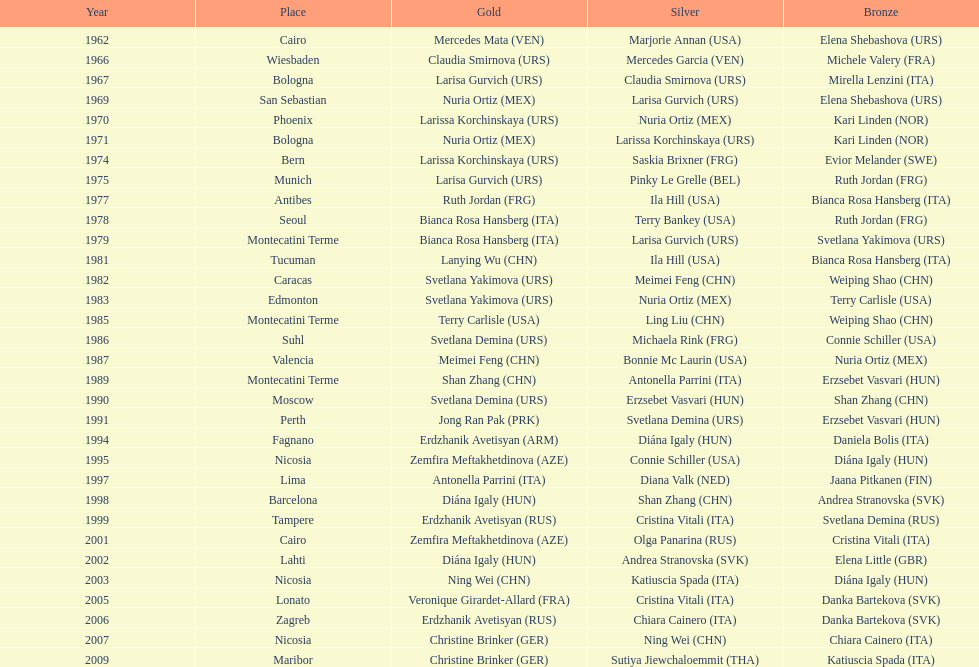What is the total of silver for cairo 0. 